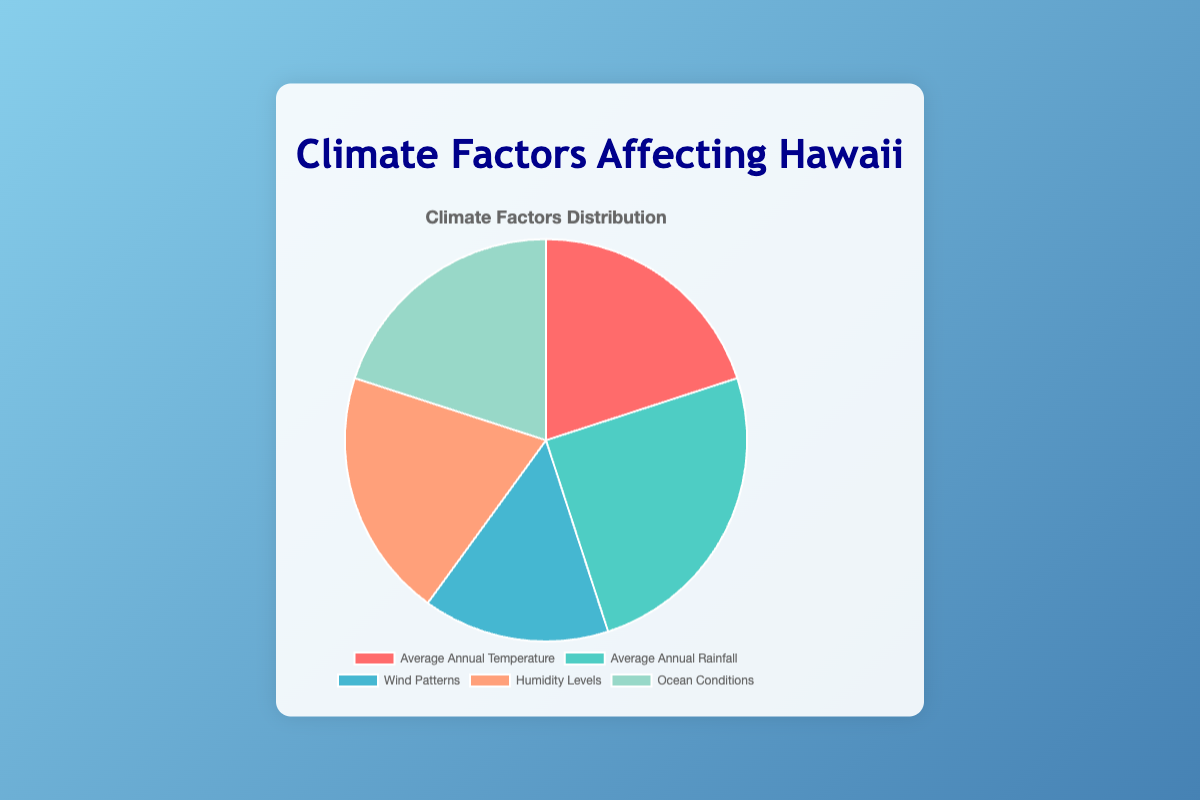What is the most significant climate factor affecting Hawaii based on the pie chart? The pie chart shows each climate factor's contribution percentage. The largest segment in the pie chart represents the most significant factor. Here, "Average Annual Rainfall" has the highest percentage at 25%.
Answer: Average Annual Rainfall What percentage do Wind Patterns and Ocean Conditions collectively represent? The pie chart provides the individual percentages for Wind Patterns (15%) and Ocean Conditions (20%). The collective percentage is obtained by summing these two values: 15% + 20% = 35%.
Answer: 35% Which three climate factors are equally significant based on their percentages? From the pie chart, "Average Annual Temperature," "Humidity Levels," and "Ocean Conditions" all share the same percentage value of 20%.
Answer: Average Annual Temperature, Humidity Levels, Ocean Conditions Between Wind Patterns and Average Annual Temperature, which one has a smaller contribution and by how much? By comparing the two percentages in the pie chart, Wind Patterns is 15% and Average Annual Temperature is 20%. The difference is: 20% - 15% = 5%.
Answer: Wind Patterns by 5% If the Average Annual Rainfall percentage was distributed equally among the other four factors, what would the new percentage for each of those factors be? First, identify the Average Annual Rainfall percentage: 25%. This value should be split equally among the four other factors. Hence, each factor would receive an additional 25% / 4 = 6.25%. For the original value of 20%, the new value is: 20% + 6.25% = 26.25%. For Wind Patterns (originally 15%), the adjusted value is: 15% + 6.25% = 21.25%.
Answer: Average Annual Temperature: 26.25%, Wind Patterns: 21.25%, Humidity Levels: 26.25%, Ocean Conditions: 26.25% Which climate factor is associated with a blue segment in the pie chart? By visually inspecting the pie chart, the blue color corresponds to "Wind Patterns".
Answer: Wind Patterns How much more significant is Average Annual Rainfall compared to Wind Patterns? The percentage for Average Annual Rainfall is 25%, while Wind Patterns is 15%. The difference between their contributions is: 25% - 15% = 10%.
Answer: 10% Arrange the climate factors from highest to lowest percentage. Based on the pie chart, the arrangement in descending order is: Average Annual Rainfall (25%), Average Annual Temperature (20%), Humidity Levels (20%), Ocean Conditions (20%), and Wind Patterns (15%).
Answer: Average Annual Rainfall, Average Annual Temperature, Humidity Levels, Ocean Conditions, Wind Patterns Identify the climate factor corresponding to the green segment of the pie chart. The green segment in the pie chart represents "Average Annual Rainfall".
Answer: Average Annual Rainfall 